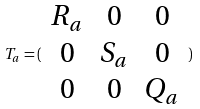<formula> <loc_0><loc_0><loc_500><loc_500>T _ { a } = ( \begin{array} { c c c } R _ { a } & 0 & 0 \\ 0 & S _ { a } & 0 \\ 0 & 0 & Q _ { a } \end{array} )</formula> 